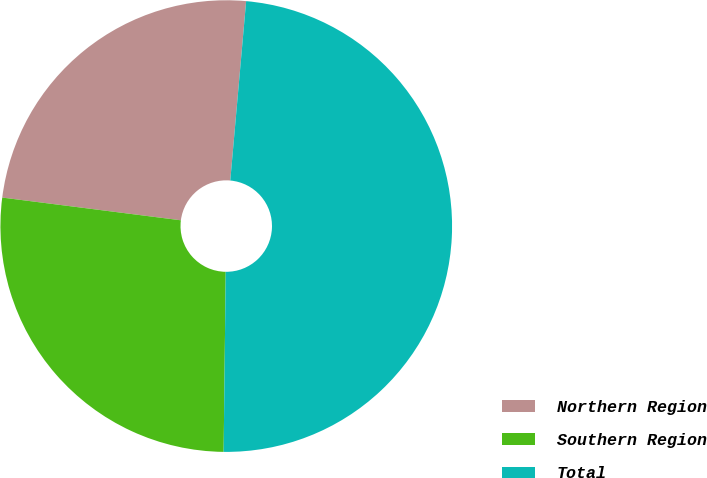Convert chart. <chart><loc_0><loc_0><loc_500><loc_500><pie_chart><fcel>Northern Region<fcel>Southern Region<fcel>Total<nl><fcel>24.39%<fcel>26.83%<fcel>48.78%<nl></chart> 